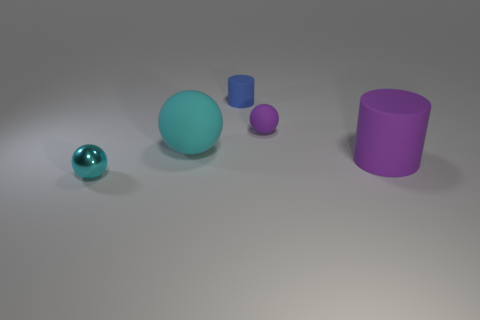Subtract all brown cylinders. How many cyan balls are left? 2 Subtract all cyan balls. How many balls are left? 1 Add 5 large green rubber cylinders. How many objects exist? 10 Subtract all cylinders. How many objects are left? 3 Subtract 0 cyan cylinders. How many objects are left? 5 Subtract all blue cylinders. Subtract all large purple spheres. How many objects are left? 4 Add 3 blue cylinders. How many blue cylinders are left? 4 Add 1 cyan spheres. How many cyan spheres exist? 3 